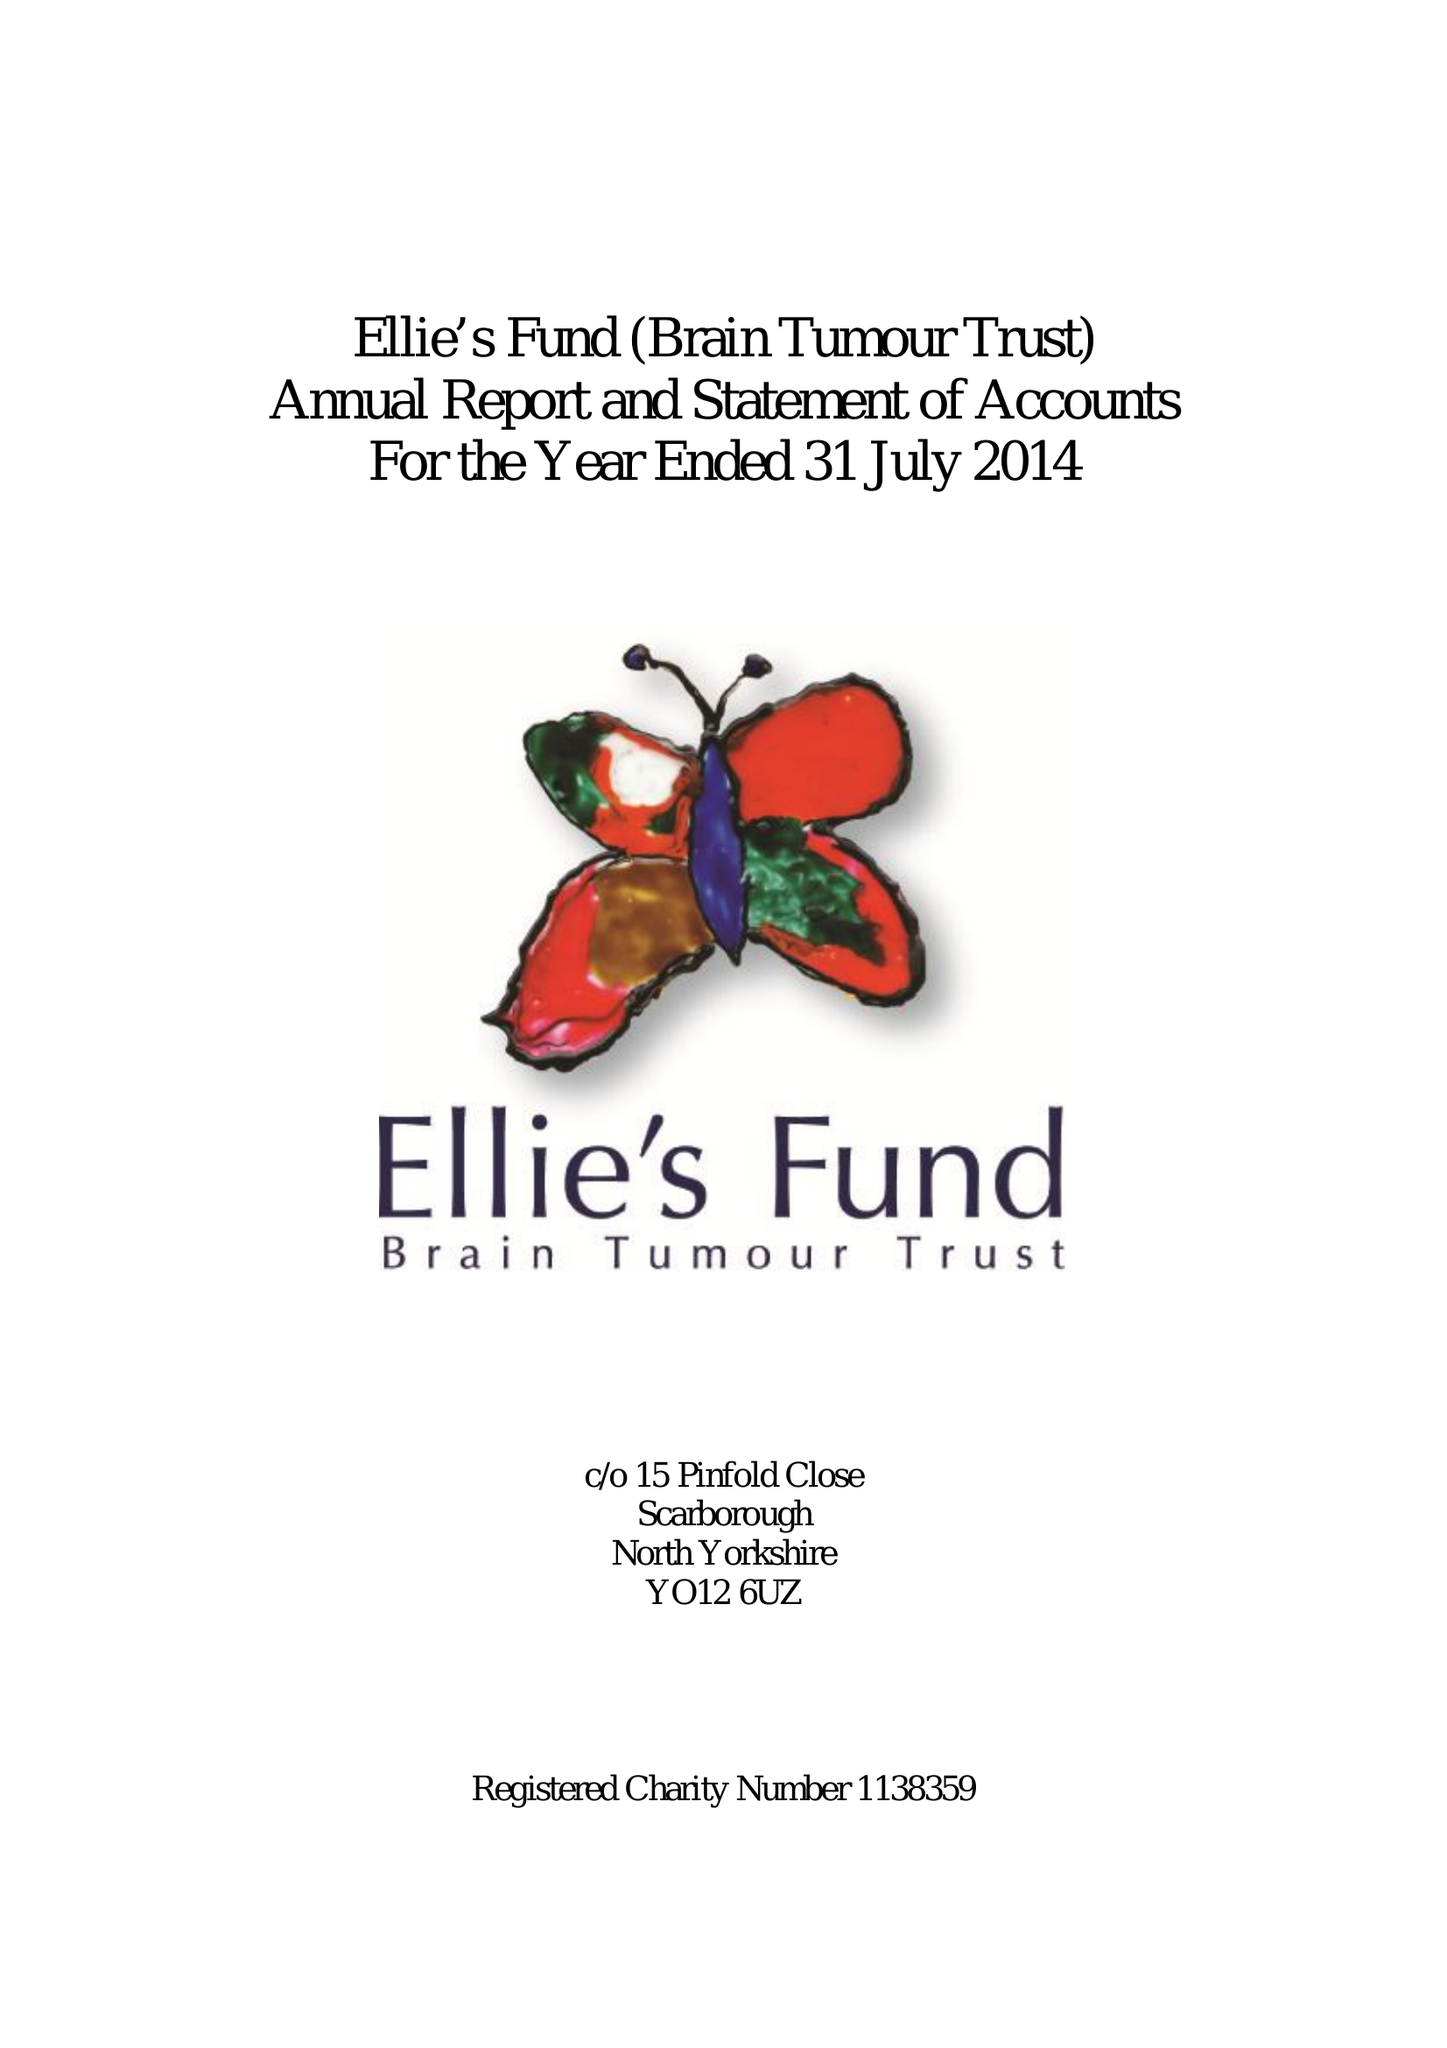What is the value for the charity_number?
Answer the question using a single word or phrase. 1138359 